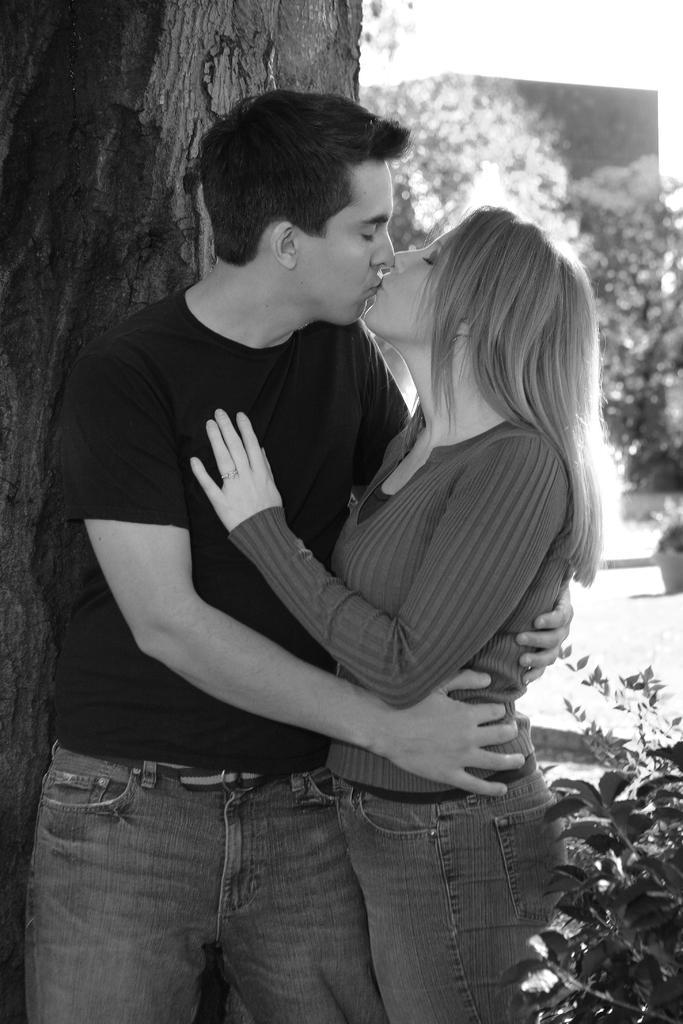Can you describe this image briefly? This picture is clicked outside. In the foreground we can see a woman and a man wearing t-shirts, standing and kissing each other and we can see the plants and the trunk of a tree. In the background we can see the trees and some objects. 